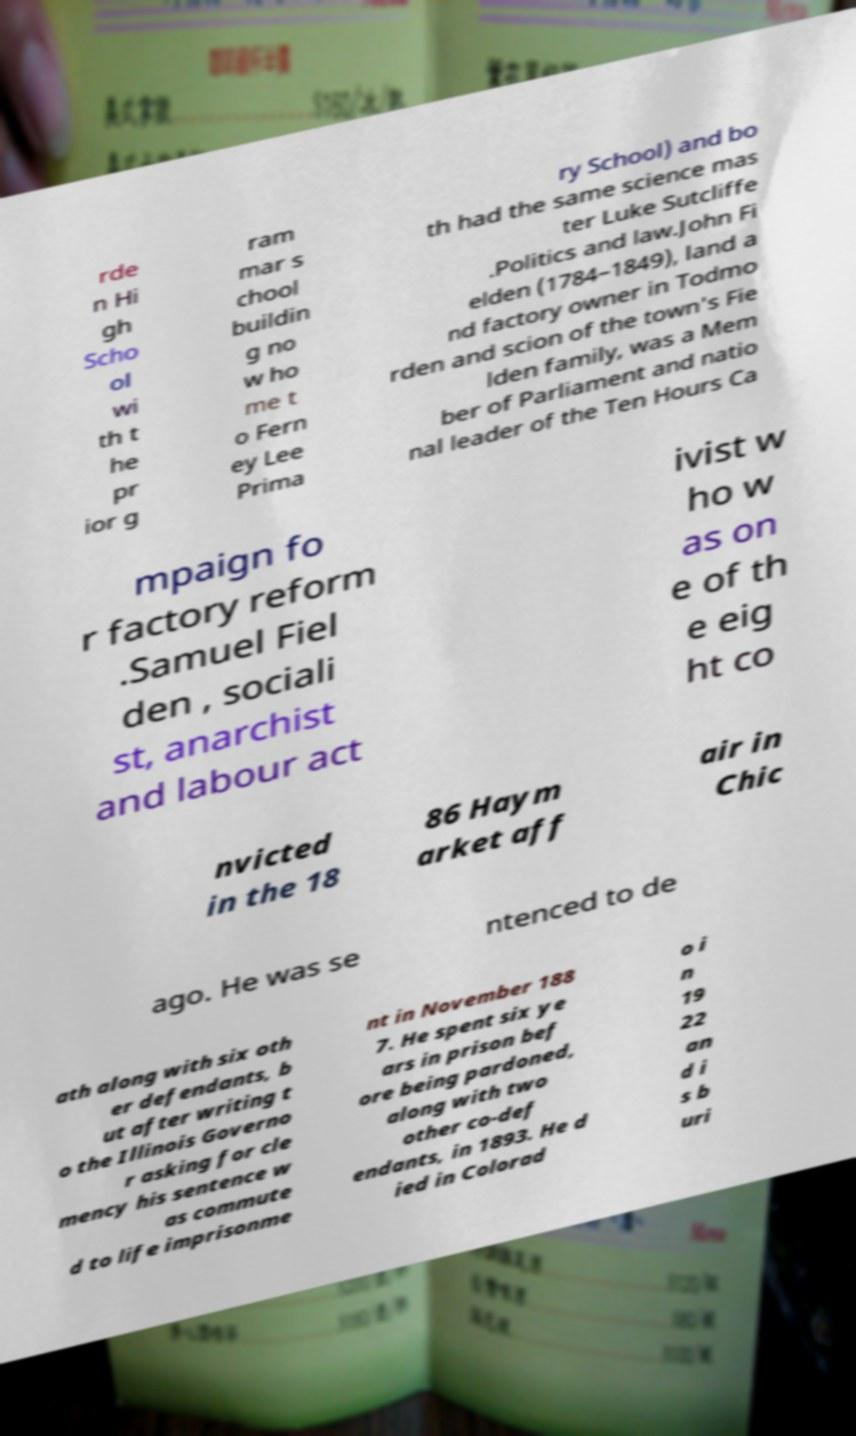What messages or text are displayed in this image? I need them in a readable, typed format. rde n Hi gh Scho ol wi th t he pr ior g ram mar s chool buildin g no w ho me t o Fern ey Lee Prima ry School) and bo th had the same science mas ter Luke Sutcliffe .Politics and law.John Fi elden (1784–1849), land a nd factory owner in Todmo rden and scion of the town's Fie lden family, was a Mem ber of Parliament and natio nal leader of the Ten Hours Ca mpaign fo r factory reform .Samuel Fiel den , sociali st, anarchist and labour act ivist w ho w as on e of th e eig ht co nvicted in the 18 86 Haym arket aff air in Chic ago. He was se ntenced to de ath along with six oth er defendants, b ut after writing t o the Illinois Governo r asking for cle mency his sentence w as commute d to life imprisonme nt in November 188 7. He spent six ye ars in prison bef ore being pardoned, along with two other co-def endants, in 1893. He d ied in Colorad o i n 19 22 an d i s b uri 